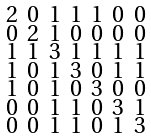Convert formula to latex. <formula><loc_0><loc_0><loc_500><loc_500>\begin{smallmatrix} 2 & 0 & 1 & 1 & 1 & 0 & 0 \\ 0 & 2 & 1 & 0 & 0 & 0 & 0 \\ 1 & 1 & 3 & 1 & 1 & 1 & 1 \\ 1 & 0 & 1 & 3 & 0 & 1 & 1 \\ 1 & 0 & 1 & 0 & 3 & 0 & 0 \\ 0 & 0 & 1 & 1 & 0 & 3 & 1 \\ 0 & 0 & 1 & 1 & 0 & 1 & 3 \end{smallmatrix}</formula> 